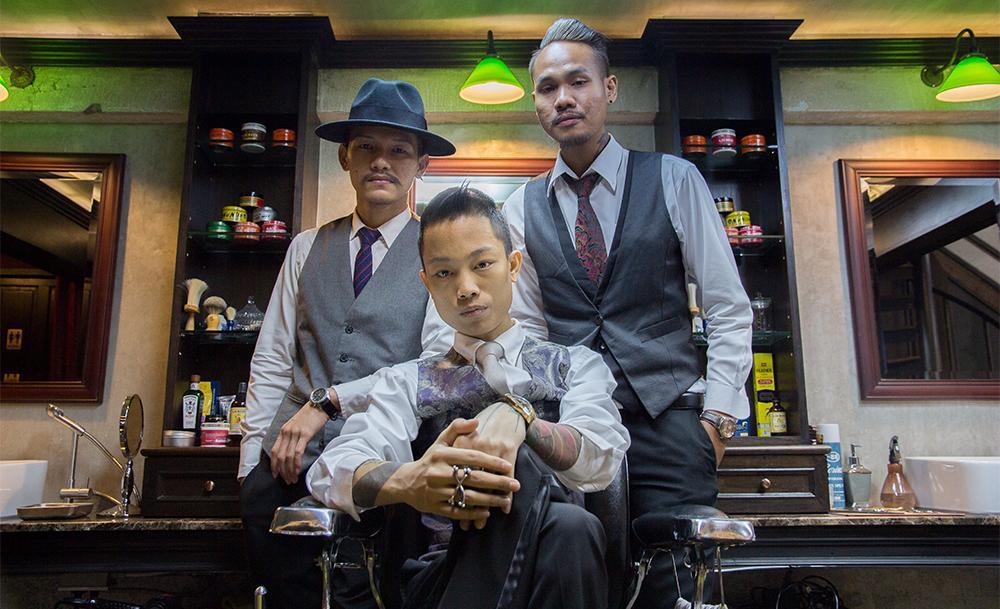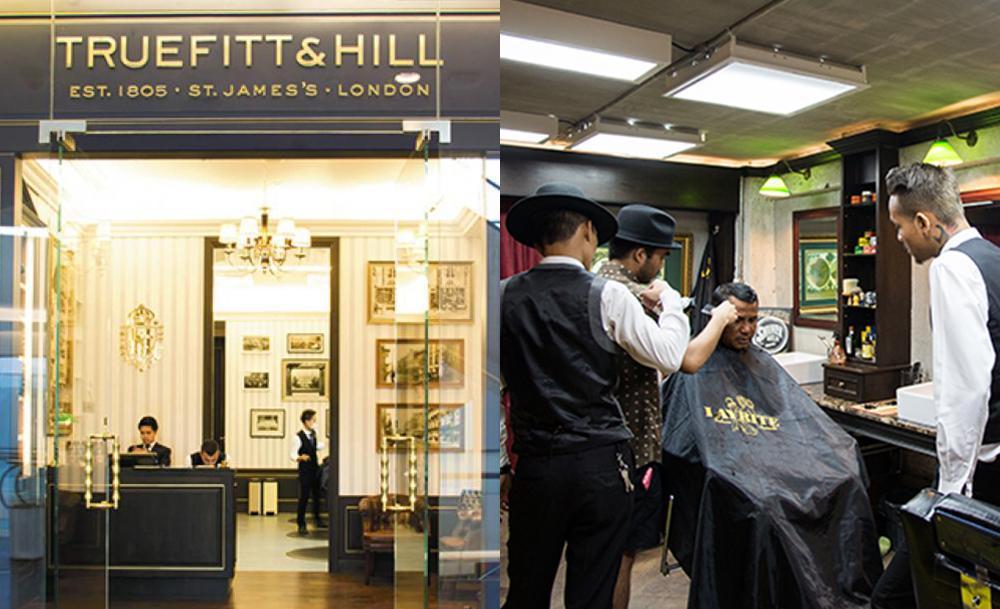The first image is the image on the left, the second image is the image on the right. Analyze the images presented: Is the assertion "Three men are sitting in barber chairs in one of the images." valid? Answer yes or no. No. The first image is the image on the left, the second image is the image on the right. Analyze the images presented: Is the assertion "In one image three men are sitting in barber chairs, one of them bald, one wearing a hat, and one with hair and no hat." valid? Answer yes or no. No. 